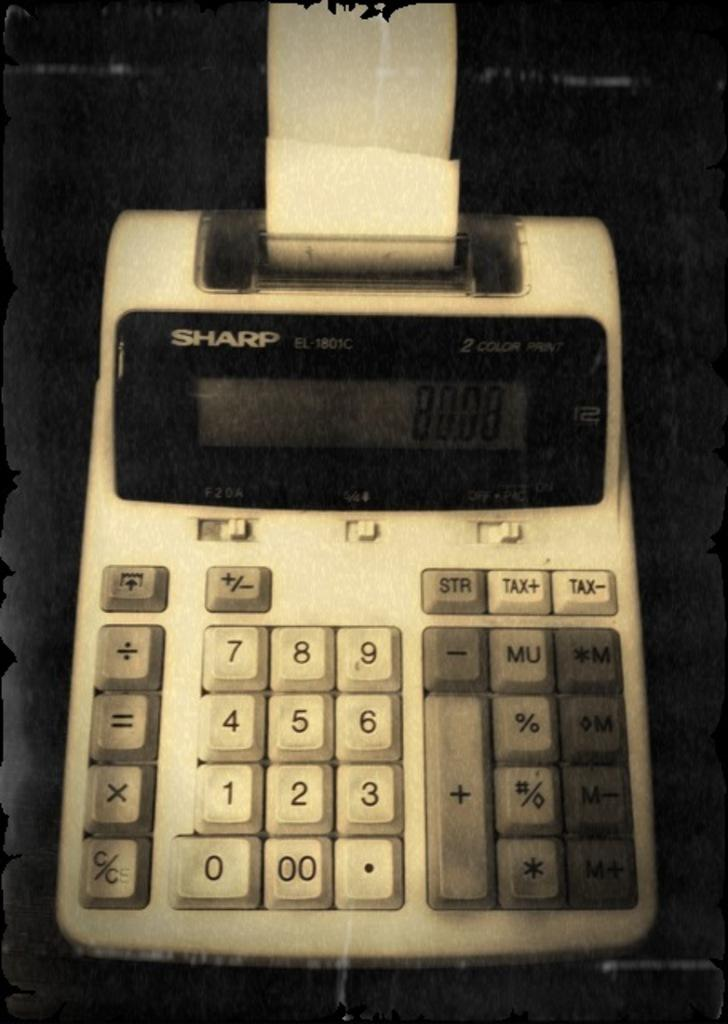<image>
Describe the image concisely. Sharp Calculator that has the numbers 8008 on the screen. 